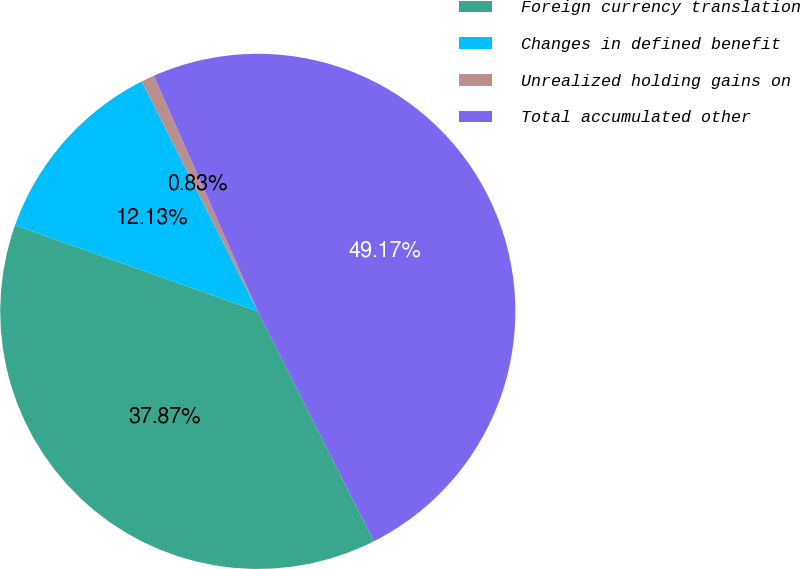Convert chart. <chart><loc_0><loc_0><loc_500><loc_500><pie_chart><fcel>Foreign currency translation<fcel>Changes in defined benefit<fcel>Unrealized holding gains on<fcel>Total accumulated other<nl><fcel>37.87%<fcel>12.13%<fcel>0.83%<fcel>49.17%<nl></chart> 